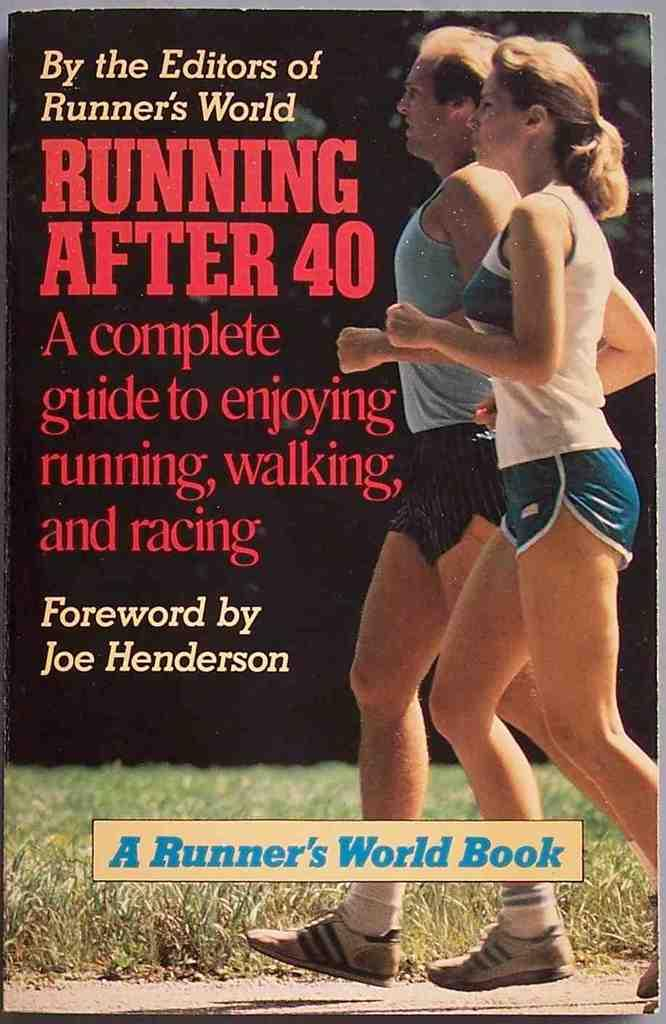<image>
Present a compact description of the photo's key features. A Runner's World book about running after 40. 